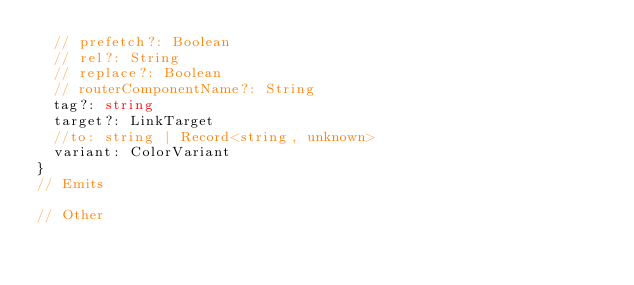Convert code to text. <code><loc_0><loc_0><loc_500><loc_500><_TypeScript_>  // prefetch?: Boolean
  // rel?: String
  // replace?: Boolean
  // routerComponentName?: String
  tag?: string
  target?: LinkTarget
  //to: string | Record<string, unknown>
  variant: ColorVariant
}
// Emits

// Other
</code> 